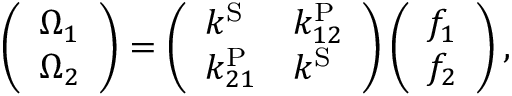<formula> <loc_0><loc_0><loc_500><loc_500>\left ( \begin{array} { l } { \Omega _ { 1 } } \\ { \Omega _ { 2 } } \end{array} \right ) = \left ( \begin{array} { l l } { k ^ { S } } & { k _ { 1 2 } ^ { P } } \\ { k _ { 2 1 } ^ { P } } & { k ^ { S } } \end{array} \right ) \left ( \begin{array} { l } { f _ { 1 } } \\ { f _ { 2 } } \end{array} \right ) ,</formula> 